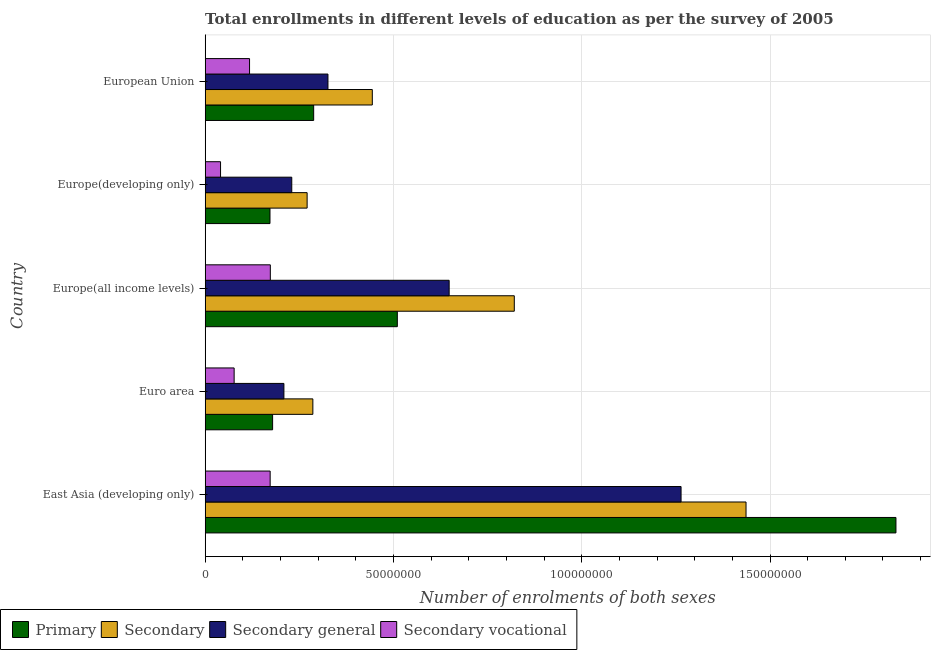Are the number of bars on each tick of the Y-axis equal?
Your response must be concise. Yes. How many bars are there on the 4th tick from the top?
Provide a succinct answer. 4. How many bars are there on the 2nd tick from the bottom?
Your answer should be very brief. 4. What is the label of the 1st group of bars from the top?
Your answer should be compact. European Union. In how many cases, is the number of bars for a given country not equal to the number of legend labels?
Provide a short and direct response. 0. What is the number of enrolments in secondary general education in Europe(developing only)?
Your response must be concise. 2.30e+07. Across all countries, what is the maximum number of enrolments in secondary education?
Offer a very short reply. 1.44e+08. Across all countries, what is the minimum number of enrolments in secondary general education?
Ensure brevity in your answer.  2.09e+07. In which country was the number of enrolments in primary education maximum?
Ensure brevity in your answer.  East Asia (developing only). In which country was the number of enrolments in primary education minimum?
Keep it short and to the point. Europe(developing only). What is the total number of enrolments in secondary education in the graph?
Ensure brevity in your answer.  3.26e+08. What is the difference between the number of enrolments in secondary general education in East Asia (developing only) and that in European Union?
Make the answer very short. 9.38e+07. What is the difference between the number of enrolments in secondary education in Europe(developing only) and the number of enrolments in secondary vocational education in Euro area?
Offer a terse response. 1.94e+07. What is the average number of enrolments in primary education per country?
Provide a short and direct response. 5.97e+07. What is the difference between the number of enrolments in primary education and number of enrolments in secondary education in European Union?
Give a very brief answer. -1.56e+07. In how many countries, is the number of enrolments in secondary education greater than 30000000 ?
Make the answer very short. 3. What is the ratio of the number of enrolments in secondary vocational education in Europe(developing only) to that in European Union?
Give a very brief answer. 0.35. Is the difference between the number of enrolments in secondary vocational education in East Asia (developing only) and Europe(all income levels) greater than the difference between the number of enrolments in secondary education in East Asia (developing only) and Europe(all income levels)?
Offer a terse response. No. What is the difference between the highest and the second highest number of enrolments in secondary general education?
Make the answer very short. 6.16e+07. What is the difference between the highest and the lowest number of enrolments in secondary vocational education?
Make the answer very short. 1.32e+07. In how many countries, is the number of enrolments in primary education greater than the average number of enrolments in primary education taken over all countries?
Provide a succinct answer. 1. Is the sum of the number of enrolments in secondary education in Europe(developing only) and European Union greater than the maximum number of enrolments in secondary general education across all countries?
Offer a very short reply. No. What does the 2nd bar from the top in Euro area represents?
Your answer should be compact. Secondary general. What does the 4th bar from the bottom in Europe(all income levels) represents?
Ensure brevity in your answer.  Secondary vocational. Does the graph contain any zero values?
Provide a short and direct response. No. Does the graph contain grids?
Offer a terse response. Yes. How many legend labels are there?
Provide a short and direct response. 4. How are the legend labels stacked?
Your response must be concise. Horizontal. What is the title of the graph?
Your response must be concise. Total enrollments in different levels of education as per the survey of 2005. What is the label or title of the X-axis?
Give a very brief answer. Number of enrolments of both sexes. What is the Number of enrolments of both sexes of Primary in East Asia (developing only)?
Make the answer very short. 1.83e+08. What is the Number of enrolments of both sexes in Secondary in East Asia (developing only)?
Give a very brief answer. 1.44e+08. What is the Number of enrolments of both sexes of Secondary general in East Asia (developing only)?
Ensure brevity in your answer.  1.26e+08. What is the Number of enrolments of both sexes in Secondary vocational in East Asia (developing only)?
Make the answer very short. 1.73e+07. What is the Number of enrolments of both sexes in Primary in Euro area?
Provide a short and direct response. 1.79e+07. What is the Number of enrolments of both sexes in Secondary in Euro area?
Provide a succinct answer. 2.86e+07. What is the Number of enrolments of both sexes in Secondary general in Euro area?
Offer a terse response. 2.09e+07. What is the Number of enrolments of both sexes in Secondary vocational in Euro area?
Give a very brief answer. 7.69e+06. What is the Number of enrolments of both sexes in Primary in Europe(all income levels)?
Keep it short and to the point. 5.10e+07. What is the Number of enrolments of both sexes of Secondary in Europe(all income levels)?
Your response must be concise. 8.21e+07. What is the Number of enrolments of both sexes in Secondary general in Europe(all income levels)?
Keep it short and to the point. 6.48e+07. What is the Number of enrolments of both sexes of Secondary vocational in Europe(all income levels)?
Give a very brief answer. 1.73e+07. What is the Number of enrolments of both sexes in Primary in Europe(developing only)?
Keep it short and to the point. 1.72e+07. What is the Number of enrolments of both sexes of Secondary in Europe(developing only)?
Keep it short and to the point. 2.71e+07. What is the Number of enrolments of both sexes in Secondary general in Europe(developing only)?
Make the answer very short. 2.30e+07. What is the Number of enrolments of both sexes in Secondary vocational in Europe(developing only)?
Your answer should be compact. 4.08e+06. What is the Number of enrolments of both sexes in Primary in European Union?
Offer a very short reply. 2.88e+07. What is the Number of enrolments of both sexes in Secondary in European Union?
Provide a short and direct response. 4.44e+07. What is the Number of enrolments of both sexes in Secondary general in European Union?
Offer a very short reply. 3.26e+07. What is the Number of enrolments of both sexes in Secondary vocational in European Union?
Offer a very short reply. 1.18e+07. Across all countries, what is the maximum Number of enrolments of both sexes in Primary?
Ensure brevity in your answer.  1.83e+08. Across all countries, what is the maximum Number of enrolments of both sexes in Secondary?
Offer a terse response. 1.44e+08. Across all countries, what is the maximum Number of enrolments of both sexes in Secondary general?
Offer a terse response. 1.26e+08. Across all countries, what is the maximum Number of enrolments of both sexes in Secondary vocational?
Offer a very short reply. 1.73e+07. Across all countries, what is the minimum Number of enrolments of both sexes in Primary?
Keep it short and to the point. 1.72e+07. Across all countries, what is the minimum Number of enrolments of both sexes of Secondary?
Provide a succinct answer. 2.71e+07. Across all countries, what is the minimum Number of enrolments of both sexes in Secondary general?
Your answer should be compact. 2.09e+07. Across all countries, what is the minimum Number of enrolments of both sexes in Secondary vocational?
Provide a short and direct response. 4.08e+06. What is the total Number of enrolments of both sexes in Primary in the graph?
Your answer should be compact. 2.98e+08. What is the total Number of enrolments of both sexes of Secondary in the graph?
Provide a succinct answer. 3.26e+08. What is the total Number of enrolments of both sexes of Secondary general in the graph?
Provide a succinct answer. 2.68e+08. What is the total Number of enrolments of both sexes of Secondary vocational in the graph?
Offer a very short reply. 5.81e+07. What is the difference between the Number of enrolments of both sexes of Primary in East Asia (developing only) and that in Euro area?
Your answer should be very brief. 1.66e+08. What is the difference between the Number of enrolments of both sexes in Secondary in East Asia (developing only) and that in Euro area?
Your answer should be compact. 1.15e+08. What is the difference between the Number of enrolments of both sexes in Secondary general in East Asia (developing only) and that in Euro area?
Provide a short and direct response. 1.05e+08. What is the difference between the Number of enrolments of both sexes in Secondary vocational in East Asia (developing only) and that in Euro area?
Provide a short and direct response. 9.57e+06. What is the difference between the Number of enrolments of both sexes in Primary in East Asia (developing only) and that in Europe(all income levels)?
Ensure brevity in your answer.  1.32e+08. What is the difference between the Number of enrolments of both sexes of Secondary in East Asia (developing only) and that in Europe(all income levels)?
Make the answer very short. 6.15e+07. What is the difference between the Number of enrolments of both sexes in Secondary general in East Asia (developing only) and that in Europe(all income levels)?
Offer a very short reply. 6.16e+07. What is the difference between the Number of enrolments of both sexes in Secondary vocational in East Asia (developing only) and that in Europe(all income levels)?
Offer a very short reply. -4.34e+04. What is the difference between the Number of enrolments of both sexes in Primary in East Asia (developing only) and that in Europe(developing only)?
Your response must be concise. 1.66e+08. What is the difference between the Number of enrolments of both sexes of Secondary in East Asia (developing only) and that in Europe(developing only)?
Offer a terse response. 1.17e+08. What is the difference between the Number of enrolments of both sexes of Secondary general in East Asia (developing only) and that in Europe(developing only)?
Your answer should be compact. 1.03e+08. What is the difference between the Number of enrolments of both sexes in Secondary vocational in East Asia (developing only) and that in Europe(developing only)?
Keep it short and to the point. 1.32e+07. What is the difference between the Number of enrolments of both sexes of Primary in East Asia (developing only) and that in European Union?
Make the answer very short. 1.55e+08. What is the difference between the Number of enrolments of both sexes of Secondary in East Asia (developing only) and that in European Union?
Ensure brevity in your answer.  9.93e+07. What is the difference between the Number of enrolments of both sexes of Secondary general in East Asia (developing only) and that in European Union?
Your answer should be very brief. 9.38e+07. What is the difference between the Number of enrolments of both sexes of Secondary vocational in East Asia (developing only) and that in European Union?
Keep it short and to the point. 5.47e+06. What is the difference between the Number of enrolments of both sexes of Primary in Euro area and that in Europe(all income levels)?
Your response must be concise. -3.31e+07. What is the difference between the Number of enrolments of both sexes in Secondary in Euro area and that in Europe(all income levels)?
Your answer should be compact. -5.35e+07. What is the difference between the Number of enrolments of both sexes in Secondary general in Euro area and that in Europe(all income levels)?
Offer a very short reply. -4.39e+07. What is the difference between the Number of enrolments of both sexes of Secondary vocational in Euro area and that in Europe(all income levels)?
Offer a very short reply. -9.61e+06. What is the difference between the Number of enrolments of both sexes of Primary in Euro area and that in Europe(developing only)?
Offer a terse response. 6.93e+05. What is the difference between the Number of enrolments of both sexes of Secondary in Euro area and that in Europe(developing only)?
Offer a very short reply. 1.52e+06. What is the difference between the Number of enrolments of both sexes in Secondary general in Euro area and that in Europe(developing only)?
Ensure brevity in your answer.  -2.09e+06. What is the difference between the Number of enrolments of both sexes of Secondary vocational in Euro area and that in Europe(developing only)?
Your response must be concise. 3.61e+06. What is the difference between the Number of enrolments of both sexes of Primary in Euro area and that in European Union?
Offer a terse response. -1.09e+07. What is the difference between the Number of enrolments of both sexes of Secondary in Euro area and that in European Union?
Your response must be concise. -1.58e+07. What is the difference between the Number of enrolments of both sexes in Secondary general in Euro area and that in European Union?
Keep it short and to the point. -1.17e+07. What is the difference between the Number of enrolments of both sexes of Secondary vocational in Euro area and that in European Union?
Keep it short and to the point. -4.09e+06. What is the difference between the Number of enrolments of both sexes in Primary in Europe(all income levels) and that in Europe(developing only)?
Offer a terse response. 3.38e+07. What is the difference between the Number of enrolments of both sexes in Secondary in Europe(all income levels) and that in Europe(developing only)?
Offer a terse response. 5.50e+07. What is the difference between the Number of enrolments of both sexes in Secondary general in Europe(all income levels) and that in Europe(developing only)?
Provide a short and direct response. 4.18e+07. What is the difference between the Number of enrolments of both sexes of Secondary vocational in Europe(all income levels) and that in Europe(developing only)?
Provide a succinct answer. 1.32e+07. What is the difference between the Number of enrolments of both sexes of Primary in Europe(all income levels) and that in European Union?
Provide a short and direct response. 2.22e+07. What is the difference between the Number of enrolments of both sexes in Secondary in Europe(all income levels) and that in European Union?
Your response must be concise. 3.77e+07. What is the difference between the Number of enrolments of both sexes in Secondary general in Europe(all income levels) and that in European Union?
Your answer should be very brief. 3.22e+07. What is the difference between the Number of enrolments of both sexes of Secondary vocational in Europe(all income levels) and that in European Union?
Offer a terse response. 5.52e+06. What is the difference between the Number of enrolments of both sexes in Primary in Europe(developing only) and that in European Union?
Offer a terse response. -1.16e+07. What is the difference between the Number of enrolments of both sexes of Secondary in Europe(developing only) and that in European Union?
Keep it short and to the point. -1.73e+07. What is the difference between the Number of enrolments of both sexes in Secondary general in Europe(developing only) and that in European Union?
Offer a very short reply. -9.61e+06. What is the difference between the Number of enrolments of both sexes in Secondary vocational in Europe(developing only) and that in European Union?
Offer a terse response. -7.70e+06. What is the difference between the Number of enrolments of both sexes of Primary in East Asia (developing only) and the Number of enrolments of both sexes of Secondary in Euro area?
Offer a very short reply. 1.55e+08. What is the difference between the Number of enrolments of both sexes in Primary in East Asia (developing only) and the Number of enrolments of both sexes in Secondary general in Euro area?
Your answer should be compact. 1.63e+08. What is the difference between the Number of enrolments of both sexes of Primary in East Asia (developing only) and the Number of enrolments of both sexes of Secondary vocational in Euro area?
Your response must be concise. 1.76e+08. What is the difference between the Number of enrolments of both sexes in Secondary in East Asia (developing only) and the Number of enrolments of both sexes in Secondary general in Euro area?
Offer a very short reply. 1.23e+08. What is the difference between the Number of enrolments of both sexes of Secondary in East Asia (developing only) and the Number of enrolments of both sexes of Secondary vocational in Euro area?
Keep it short and to the point. 1.36e+08. What is the difference between the Number of enrolments of both sexes in Secondary general in East Asia (developing only) and the Number of enrolments of both sexes in Secondary vocational in Euro area?
Offer a terse response. 1.19e+08. What is the difference between the Number of enrolments of both sexes in Primary in East Asia (developing only) and the Number of enrolments of both sexes in Secondary in Europe(all income levels)?
Make the answer very short. 1.01e+08. What is the difference between the Number of enrolments of both sexes in Primary in East Asia (developing only) and the Number of enrolments of both sexes in Secondary general in Europe(all income levels)?
Provide a short and direct response. 1.19e+08. What is the difference between the Number of enrolments of both sexes of Primary in East Asia (developing only) and the Number of enrolments of both sexes of Secondary vocational in Europe(all income levels)?
Offer a terse response. 1.66e+08. What is the difference between the Number of enrolments of both sexes of Secondary in East Asia (developing only) and the Number of enrolments of both sexes of Secondary general in Europe(all income levels)?
Provide a short and direct response. 7.88e+07. What is the difference between the Number of enrolments of both sexes in Secondary in East Asia (developing only) and the Number of enrolments of both sexes in Secondary vocational in Europe(all income levels)?
Your answer should be very brief. 1.26e+08. What is the difference between the Number of enrolments of both sexes of Secondary general in East Asia (developing only) and the Number of enrolments of both sexes of Secondary vocational in Europe(all income levels)?
Provide a succinct answer. 1.09e+08. What is the difference between the Number of enrolments of both sexes in Primary in East Asia (developing only) and the Number of enrolments of both sexes in Secondary in Europe(developing only)?
Keep it short and to the point. 1.56e+08. What is the difference between the Number of enrolments of both sexes in Primary in East Asia (developing only) and the Number of enrolments of both sexes in Secondary general in Europe(developing only)?
Your response must be concise. 1.60e+08. What is the difference between the Number of enrolments of both sexes in Primary in East Asia (developing only) and the Number of enrolments of both sexes in Secondary vocational in Europe(developing only)?
Your answer should be compact. 1.79e+08. What is the difference between the Number of enrolments of both sexes of Secondary in East Asia (developing only) and the Number of enrolments of both sexes of Secondary general in Europe(developing only)?
Your answer should be very brief. 1.21e+08. What is the difference between the Number of enrolments of both sexes of Secondary in East Asia (developing only) and the Number of enrolments of both sexes of Secondary vocational in Europe(developing only)?
Offer a very short reply. 1.40e+08. What is the difference between the Number of enrolments of both sexes in Secondary general in East Asia (developing only) and the Number of enrolments of both sexes in Secondary vocational in Europe(developing only)?
Your response must be concise. 1.22e+08. What is the difference between the Number of enrolments of both sexes of Primary in East Asia (developing only) and the Number of enrolments of both sexes of Secondary in European Union?
Offer a terse response. 1.39e+08. What is the difference between the Number of enrolments of both sexes of Primary in East Asia (developing only) and the Number of enrolments of both sexes of Secondary general in European Union?
Provide a short and direct response. 1.51e+08. What is the difference between the Number of enrolments of both sexes in Primary in East Asia (developing only) and the Number of enrolments of both sexes in Secondary vocational in European Union?
Your answer should be very brief. 1.72e+08. What is the difference between the Number of enrolments of both sexes of Secondary in East Asia (developing only) and the Number of enrolments of both sexes of Secondary general in European Union?
Your response must be concise. 1.11e+08. What is the difference between the Number of enrolments of both sexes in Secondary in East Asia (developing only) and the Number of enrolments of both sexes in Secondary vocational in European Union?
Provide a succinct answer. 1.32e+08. What is the difference between the Number of enrolments of both sexes of Secondary general in East Asia (developing only) and the Number of enrolments of both sexes of Secondary vocational in European Union?
Keep it short and to the point. 1.15e+08. What is the difference between the Number of enrolments of both sexes of Primary in Euro area and the Number of enrolments of both sexes of Secondary in Europe(all income levels)?
Offer a terse response. -6.42e+07. What is the difference between the Number of enrolments of both sexes of Primary in Euro area and the Number of enrolments of both sexes of Secondary general in Europe(all income levels)?
Make the answer very short. -4.69e+07. What is the difference between the Number of enrolments of both sexes of Primary in Euro area and the Number of enrolments of both sexes of Secondary vocational in Europe(all income levels)?
Your answer should be compact. 6.05e+05. What is the difference between the Number of enrolments of both sexes of Secondary in Euro area and the Number of enrolments of both sexes of Secondary general in Europe(all income levels)?
Make the answer very short. -3.62e+07. What is the difference between the Number of enrolments of both sexes in Secondary in Euro area and the Number of enrolments of both sexes in Secondary vocational in Europe(all income levels)?
Keep it short and to the point. 1.13e+07. What is the difference between the Number of enrolments of both sexes of Secondary general in Euro area and the Number of enrolments of both sexes of Secondary vocational in Europe(all income levels)?
Provide a succinct answer. 3.61e+06. What is the difference between the Number of enrolments of both sexes of Primary in Euro area and the Number of enrolments of both sexes of Secondary in Europe(developing only)?
Ensure brevity in your answer.  -9.17e+06. What is the difference between the Number of enrolments of both sexes of Primary in Euro area and the Number of enrolments of both sexes of Secondary general in Europe(developing only)?
Provide a short and direct response. -5.09e+06. What is the difference between the Number of enrolments of both sexes of Primary in Euro area and the Number of enrolments of both sexes of Secondary vocational in Europe(developing only)?
Offer a terse response. 1.38e+07. What is the difference between the Number of enrolments of both sexes in Secondary in Euro area and the Number of enrolments of both sexes in Secondary general in Europe(developing only)?
Your answer should be compact. 5.60e+06. What is the difference between the Number of enrolments of both sexes in Secondary in Euro area and the Number of enrolments of both sexes in Secondary vocational in Europe(developing only)?
Offer a very short reply. 2.45e+07. What is the difference between the Number of enrolments of both sexes of Secondary general in Euro area and the Number of enrolments of both sexes of Secondary vocational in Europe(developing only)?
Provide a succinct answer. 1.68e+07. What is the difference between the Number of enrolments of both sexes in Primary in Euro area and the Number of enrolments of both sexes in Secondary in European Union?
Your response must be concise. -2.65e+07. What is the difference between the Number of enrolments of both sexes in Primary in Euro area and the Number of enrolments of both sexes in Secondary general in European Union?
Ensure brevity in your answer.  -1.47e+07. What is the difference between the Number of enrolments of both sexes in Primary in Euro area and the Number of enrolments of both sexes in Secondary vocational in European Union?
Ensure brevity in your answer.  6.12e+06. What is the difference between the Number of enrolments of both sexes of Secondary in Euro area and the Number of enrolments of both sexes of Secondary general in European Union?
Keep it short and to the point. -4.01e+06. What is the difference between the Number of enrolments of both sexes in Secondary in Euro area and the Number of enrolments of both sexes in Secondary vocational in European Union?
Ensure brevity in your answer.  1.68e+07. What is the difference between the Number of enrolments of both sexes in Secondary general in Euro area and the Number of enrolments of both sexes in Secondary vocational in European Union?
Give a very brief answer. 9.13e+06. What is the difference between the Number of enrolments of both sexes in Primary in Europe(all income levels) and the Number of enrolments of both sexes in Secondary in Europe(developing only)?
Your answer should be compact. 2.40e+07. What is the difference between the Number of enrolments of both sexes of Primary in Europe(all income levels) and the Number of enrolments of both sexes of Secondary general in Europe(developing only)?
Offer a terse response. 2.80e+07. What is the difference between the Number of enrolments of both sexes in Primary in Europe(all income levels) and the Number of enrolments of both sexes in Secondary vocational in Europe(developing only)?
Your response must be concise. 4.69e+07. What is the difference between the Number of enrolments of both sexes of Secondary in Europe(all income levels) and the Number of enrolments of both sexes of Secondary general in Europe(developing only)?
Your response must be concise. 5.91e+07. What is the difference between the Number of enrolments of both sexes in Secondary in Europe(all income levels) and the Number of enrolments of both sexes in Secondary vocational in Europe(developing only)?
Your answer should be compact. 7.80e+07. What is the difference between the Number of enrolments of both sexes of Secondary general in Europe(all income levels) and the Number of enrolments of both sexes of Secondary vocational in Europe(developing only)?
Offer a terse response. 6.07e+07. What is the difference between the Number of enrolments of both sexes in Primary in Europe(all income levels) and the Number of enrolments of both sexes in Secondary in European Union?
Offer a terse response. 6.65e+06. What is the difference between the Number of enrolments of both sexes in Primary in Europe(all income levels) and the Number of enrolments of both sexes in Secondary general in European Union?
Offer a very short reply. 1.84e+07. What is the difference between the Number of enrolments of both sexes of Primary in Europe(all income levels) and the Number of enrolments of both sexes of Secondary vocational in European Union?
Give a very brief answer. 3.92e+07. What is the difference between the Number of enrolments of both sexes of Secondary in Europe(all income levels) and the Number of enrolments of both sexes of Secondary general in European Union?
Give a very brief answer. 4.95e+07. What is the difference between the Number of enrolments of both sexes of Secondary in Europe(all income levels) and the Number of enrolments of both sexes of Secondary vocational in European Union?
Ensure brevity in your answer.  7.03e+07. What is the difference between the Number of enrolments of both sexes in Secondary general in Europe(all income levels) and the Number of enrolments of both sexes in Secondary vocational in European Union?
Give a very brief answer. 5.30e+07. What is the difference between the Number of enrolments of both sexes of Primary in Europe(developing only) and the Number of enrolments of both sexes of Secondary in European Union?
Offer a terse response. -2.72e+07. What is the difference between the Number of enrolments of both sexes of Primary in Europe(developing only) and the Number of enrolments of both sexes of Secondary general in European Union?
Ensure brevity in your answer.  -1.54e+07. What is the difference between the Number of enrolments of both sexes in Primary in Europe(developing only) and the Number of enrolments of both sexes in Secondary vocational in European Union?
Keep it short and to the point. 5.43e+06. What is the difference between the Number of enrolments of both sexes in Secondary in Europe(developing only) and the Number of enrolments of both sexes in Secondary general in European Union?
Provide a short and direct response. -5.53e+06. What is the difference between the Number of enrolments of both sexes of Secondary in Europe(developing only) and the Number of enrolments of both sexes of Secondary vocational in European Union?
Ensure brevity in your answer.  1.53e+07. What is the difference between the Number of enrolments of both sexes of Secondary general in Europe(developing only) and the Number of enrolments of both sexes of Secondary vocational in European Union?
Offer a very short reply. 1.12e+07. What is the average Number of enrolments of both sexes in Primary per country?
Give a very brief answer. 5.97e+07. What is the average Number of enrolments of both sexes in Secondary per country?
Ensure brevity in your answer.  6.52e+07. What is the average Number of enrolments of both sexes of Secondary general per country?
Ensure brevity in your answer.  5.35e+07. What is the average Number of enrolments of both sexes of Secondary vocational per country?
Offer a terse response. 1.16e+07. What is the difference between the Number of enrolments of both sexes of Primary and Number of enrolments of both sexes of Secondary in East Asia (developing only)?
Make the answer very short. 3.98e+07. What is the difference between the Number of enrolments of both sexes in Primary and Number of enrolments of both sexes in Secondary general in East Asia (developing only)?
Offer a very short reply. 5.71e+07. What is the difference between the Number of enrolments of both sexes in Primary and Number of enrolments of both sexes in Secondary vocational in East Asia (developing only)?
Ensure brevity in your answer.  1.66e+08. What is the difference between the Number of enrolments of both sexes in Secondary and Number of enrolments of both sexes in Secondary general in East Asia (developing only)?
Ensure brevity in your answer.  1.73e+07. What is the difference between the Number of enrolments of both sexes of Secondary and Number of enrolments of both sexes of Secondary vocational in East Asia (developing only)?
Your answer should be compact. 1.26e+08. What is the difference between the Number of enrolments of both sexes of Secondary general and Number of enrolments of both sexes of Secondary vocational in East Asia (developing only)?
Provide a succinct answer. 1.09e+08. What is the difference between the Number of enrolments of both sexes of Primary and Number of enrolments of both sexes of Secondary in Euro area?
Give a very brief answer. -1.07e+07. What is the difference between the Number of enrolments of both sexes in Primary and Number of enrolments of both sexes in Secondary general in Euro area?
Ensure brevity in your answer.  -3.00e+06. What is the difference between the Number of enrolments of both sexes of Primary and Number of enrolments of both sexes of Secondary vocational in Euro area?
Keep it short and to the point. 1.02e+07. What is the difference between the Number of enrolments of both sexes in Secondary and Number of enrolments of both sexes in Secondary general in Euro area?
Offer a terse response. 7.69e+06. What is the difference between the Number of enrolments of both sexes in Secondary and Number of enrolments of both sexes in Secondary vocational in Euro area?
Offer a very short reply. 2.09e+07. What is the difference between the Number of enrolments of both sexes in Secondary general and Number of enrolments of both sexes in Secondary vocational in Euro area?
Offer a terse response. 1.32e+07. What is the difference between the Number of enrolments of both sexes of Primary and Number of enrolments of both sexes of Secondary in Europe(all income levels)?
Offer a terse response. -3.11e+07. What is the difference between the Number of enrolments of both sexes of Primary and Number of enrolments of both sexes of Secondary general in Europe(all income levels)?
Give a very brief answer. -1.38e+07. What is the difference between the Number of enrolments of both sexes of Primary and Number of enrolments of both sexes of Secondary vocational in Europe(all income levels)?
Your answer should be very brief. 3.37e+07. What is the difference between the Number of enrolments of both sexes of Secondary and Number of enrolments of both sexes of Secondary general in Europe(all income levels)?
Provide a succinct answer. 1.73e+07. What is the difference between the Number of enrolments of both sexes of Secondary and Number of enrolments of both sexes of Secondary vocational in Europe(all income levels)?
Provide a succinct answer. 6.48e+07. What is the difference between the Number of enrolments of both sexes in Secondary general and Number of enrolments of both sexes in Secondary vocational in Europe(all income levels)?
Keep it short and to the point. 4.75e+07. What is the difference between the Number of enrolments of both sexes in Primary and Number of enrolments of both sexes in Secondary in Europe(developing only)?
Your answer should be very brief. -9.86e+06. What is the difference between the Number of enrolments of both sexes in Primary and Number of enrolments of both sexes in Secondary general in Europe(developing only)?
Your answer should be very brief. -5.78e+06. What is the difference between the Number of enrolments of both sexes in Primary and Number of enrolments of both sexes in Secondary vocational in Europe(developing only)?
Give a very brief answer. 1.31e+07. What is the difference between the Number of enrolments of both sexes in Secondary and Number of enrolments of both sexes in Secondary general in Europe(developing only)?
Your response must be concise. 4.08e+06. What is the difference between the Number of enrolments of both sexes in Secondary and Number of enrolments of both sexes in Secondary vocational in Europe(developing only)?
Keep it short and to the point. 2.30e+07. What is the difference between the Number of enrolments of both sexes of Secondary general and Number of enrolments of both sexes of Secondary vocational in Europe(developing only)?
Keep it short and to the point. 1.89e+07. What is the difference between the Number of enrolments of both sexes in Primary and Number of enrolments of both sexes in Secondary in European Union?
Provide a succinct answer. -1.56e+07. What is the difference between the Number of enrolments of both sexes in Primary and Number of enrolments of both sexes in Secondary general in European Union?
Provide a succinct answer. -3.79e+06. What is the difference between the Number of enrolments of both sexes of Primary and Number of enrolments of both sexes of Secondary vocational in European Union?
Give a very brief answer. 1.70e+07. What is the difference between the Number of enrolments of both sexes in Secondary and Number of enrolments of both sexes in Secondary general in European Union?
Give a very brief answer. 1.18e+07. What is the difference between the Number of enrolments of both sexes in Secondary and Number of enrolments of both sexes in Secondary vocational in European Union?
Your answer should be very brief. 3.26e+07. What is the difference between the Number of enrolments of both sexes of Secondary general and Number of enrolments of both sexes of Secondary vocational in European Union?
Your response must be concise. 2.08e+07. What is the ratio of the Number of enrolments of both sexes in Primary in East Asia (developing only) to that in Euro area?
Give a very brief answer. 10.25. What is the ratio of the Number of enrolments of both sexes in Secondary in East Asia (developing only) to that in Euro area?
Give a very brief answer. 5.02. What is the ratio of the Number of enrolments of both sexes in Secondary general in East Asia (developing only) to that in Euro area?
Offer a very short reply. 6.05. What is the ratio of the Number of enrolments of both sexes in Secondary vocational in East Asia (developing only) to that in Euro area?
Provide a succinct answer. 2.24. What is the ratio of the Number of enrolments of both sexes of Primary in East Asia (developing only) to that in Europe(all income levels)?
Make the answer very short. 3.6. What is the ratio of the Number of enrolments of both sexes of Secondary in East Asia (developing only) to that in Europe(all income levels)?
Offer a terse response. 1.75. What is the ratio of the Number of enrolments of both sexes of Secondary general in East Asia (developing only) to that in Europe(all income levels)?
Keep it short and to the point. 1.95. What is the ratio of the Number of enrolments of both sexes of Primary in East Asia (developing only) to that in Europe(developing only)?
Your response must be concise. 10.66. What is the ratio of the Number of enrolments of both sexes in Secondary in East Asia (developing only) to that in Europe(developing only)?
Provide a short and direct response. 5.31. What is the ratio of the Number of enrolments of both sexes of Secondary general in East Asia (developing only) to that in Europe(developing only)?
Give a very brief answer. 5.5. What is the ratio of the Number of enrolments of both sexes of Secondary vocational in East Asia (developing only) to that in Europe(developing only)?
Give a very brief answer. 4.23. What is the ratio of the Number of enrolments of both sexes in Primary in East Asia (developing only) to that in European Union?
Your response must be concise. 6.37. What is the ratio of the Number of enrolments of both sexes of Secondary in East Asia (developing only) to that in European Union?
Provide a short and direct response. 3.24. What is the ratio of the Number of enrolments of both sexes in Secondary general in East Asia (developing only) to that in European Union?
Offer a very short reply. 3.88. What is the ratio of the Number of enrolments of both sexes in Secondary vocational in East Asia (developing only) to that in European Union?
Keep it short and to the point. 1.46. What is the ratio of the Number of enrolments of both sexes of Primary in Euro area to that in Europe(all income levels)?
Provide a short and direct response. 0.35. What is the ratio of the Number of enrolments of both sexes in Secondary in Euro area to that in Europe(all income levels)?
Ensure brevity in your answer.  0.35. What is the ratio of the Number of enrolments of both sexes in Secondary general in Euro area to that in Europe(all income levels)?
Offer a very short reply. 0.32. What is the ratio of the Number of enrolments of both sexes of Secondary vocational in Euro area to that in Europe(all income levels)?
Offer a terse response. 0.44. What is the ratio of the Number of enrolments of both sexes in Primary in Euro area to that in Europe(developing only)?
Offer a very short reply. 1.04. What is the ratio of the Number of enrolments of both sexes of Secondary in Euro area to that in Europe(developing only)?
Ensure brevity in your answer.  1.06. What is the ratio of the Number of enrolments of both sexes of Secondary general in Euro area to that in Europe(developing only)?
Keep it short and to the point. 0.91. What is the ratio of the Number of enrolments of both sexes of Secondary vocational in Euro area to that in Europe(developing only)?
Offer a very short reply. 1.88. What is the ratio of the Number of enrolments of both sexes in Primary in Euro area to that in European Union?
Make the answer very short. 0.62. What is the ratio of the Number of enrolments of both sexes of Secondary in Euro area to that in European Union?
Provide a short and direct response. 0.64. What is the ratio of the Number of enrolments of both sexes of Secondary general in Euro area to that in European Union?
Give a very brief answer. 0.64. What is the ratio of the Number of enrolments of both sexes of Secondary vocational in Euro area to that in European Union?
Make the answer very short. 0.65. What is the ratio of the Number of enrolments of both sexes of Primary in Europe(all income levels) to that in Europe(developing only)?
Make the answer very short. 2.97. What is the ratio of the Number of enrolments of both sexes of Secondary in Europe(all income levels) to that in Europe(developing only)?
Give a very brief answer. 3.03. What is the ratio of the Number of enrolments of both sexes in Secondary general in Europe(all income levels) to that in Europe(developing only)?
Offer a terse response. 2.82. What is the ratio of the Number of enrolments of both sexes of Secondary vocational in Europe(all income levels) to that in Europe(developing only)?
Offer a very short reply. 4.24. What is the ratio of the Number of enrolments of both sexes of Primary in Europe(all income levels) to that in European Union?
Give a very brief answer. 1.77. What is the ratio of the Number of enrolments of both sexes in Secondary in Europe(all income levels) to that in European Union?
Make the answer very short. 1.85. What is the ratio of the Number of enrolments of both sexes of Secondary general in Europe(all income levels) to that in European Union?
Provide a succinct answer. 1.99. What is the ratio of the Number of enrolments of both sexes in Secondary vocational in Europe(all income levels) to that in European Union?
Offer a very short reply. 1.47. What is the ratio of the Number of enrolments of both sexes in Primary in Europe(developing only) to that in European Union?
Offer a very short reply. 0.6. What is the ratio of the Number of enrolments of both sexes of Secondary in Europe(developing only) to that in European Union?
Your response must be concise. 0.61. What is the ratio of the Number of enrolments of both sexes of Secondary general in Europe(developing only) to that in European Union?
Make the answer very short. 0.71. What is the ratio of the Number of enrolments of both sexes of Secondary vocational in Europe(developing only) to that in European Union?
Ensure brevity in your answer.  0.35. What is the difference between the highest and the second highest Number of enrolments of both sexes in Primary?
Your answer should be very brief. 1.32e+08. What is the difference between the highest and the second highest Number of enrolments of both sexes of Secondary?
Make the answer very short. 6.15e+07. What is the difference between the highest and the second highest Number of enrolments of both sexes of Secondary general?
Offer a terse response. 6.16e+07. What is the difference between the highest and the second highest Number of enrolments of both sexes in Secondary vocational?
Give a very brief answer. 4.34e+04. What is the difference between the highest and the lowest Number of enrolments of both sexes of Primary?
Your answer should be very brief. 1.66e+08. What is the difference between the highest and the lowest Number of enrolments of both sexes in Secondary?
Your answer should be very brief. 1.17e+08. What is the difference between the highest and the lowest Number of enrolments of both sexes in Secondary general?
Keep it short and to the point. 1.05e+08. What is the difference between the highest and the lowest Number of enrolments of both sexes in Secondary vocational?
Ensure brevity in your answer.  1.32e+07. 